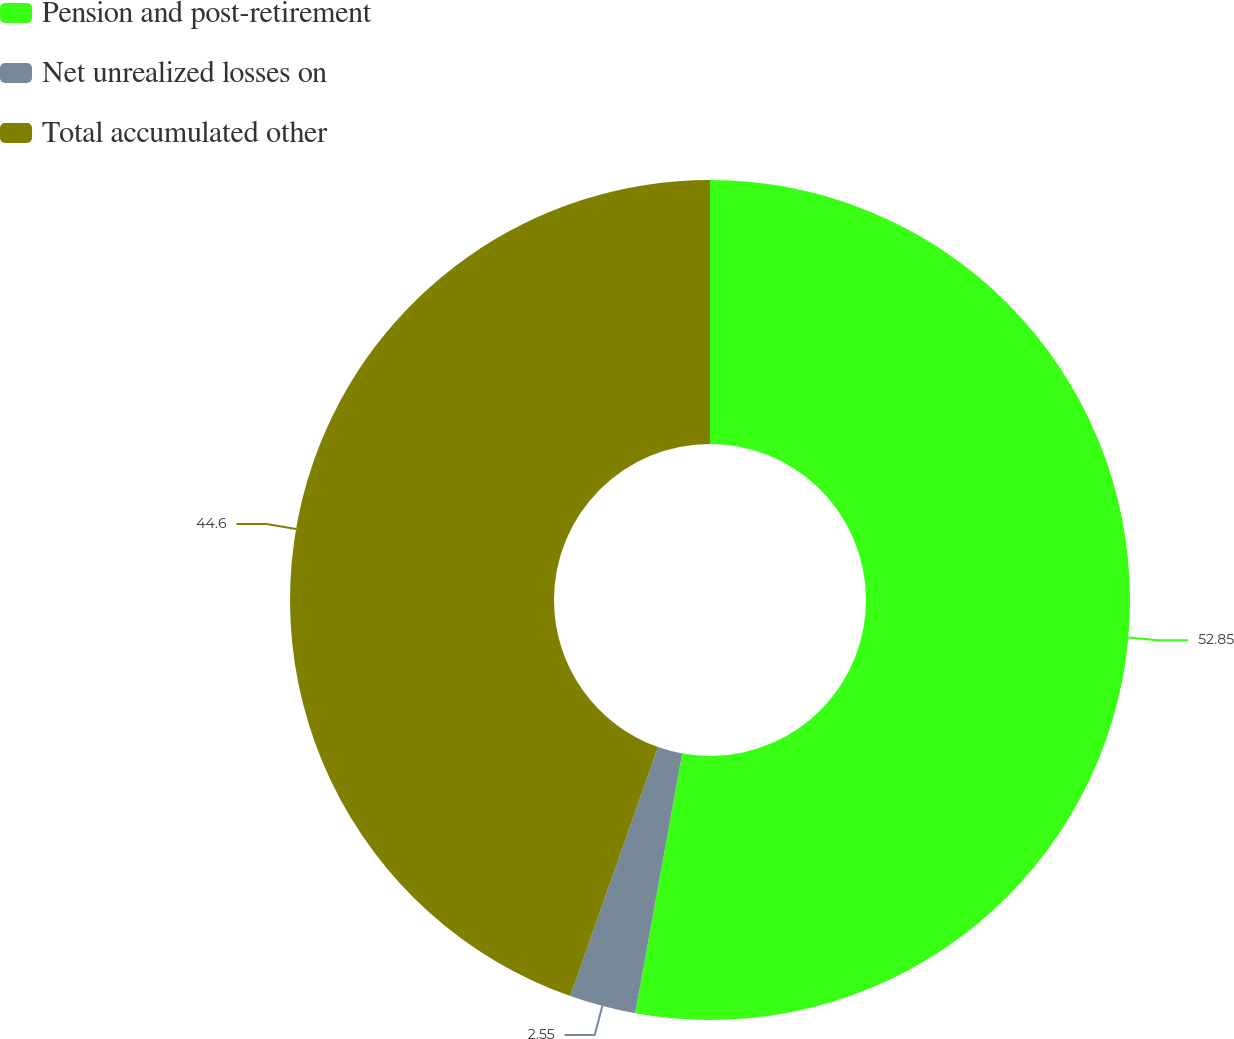<chart> <loc_0><loc_0><loc_500><loc_500><pie_chart><fcel>Pension and post-retirement<fcel>Net unrealized losses on<fcel>Total accumulated other<nl><fcel>52.85%<fcel>2.55%<fcel>44.6%<nl></chart> 